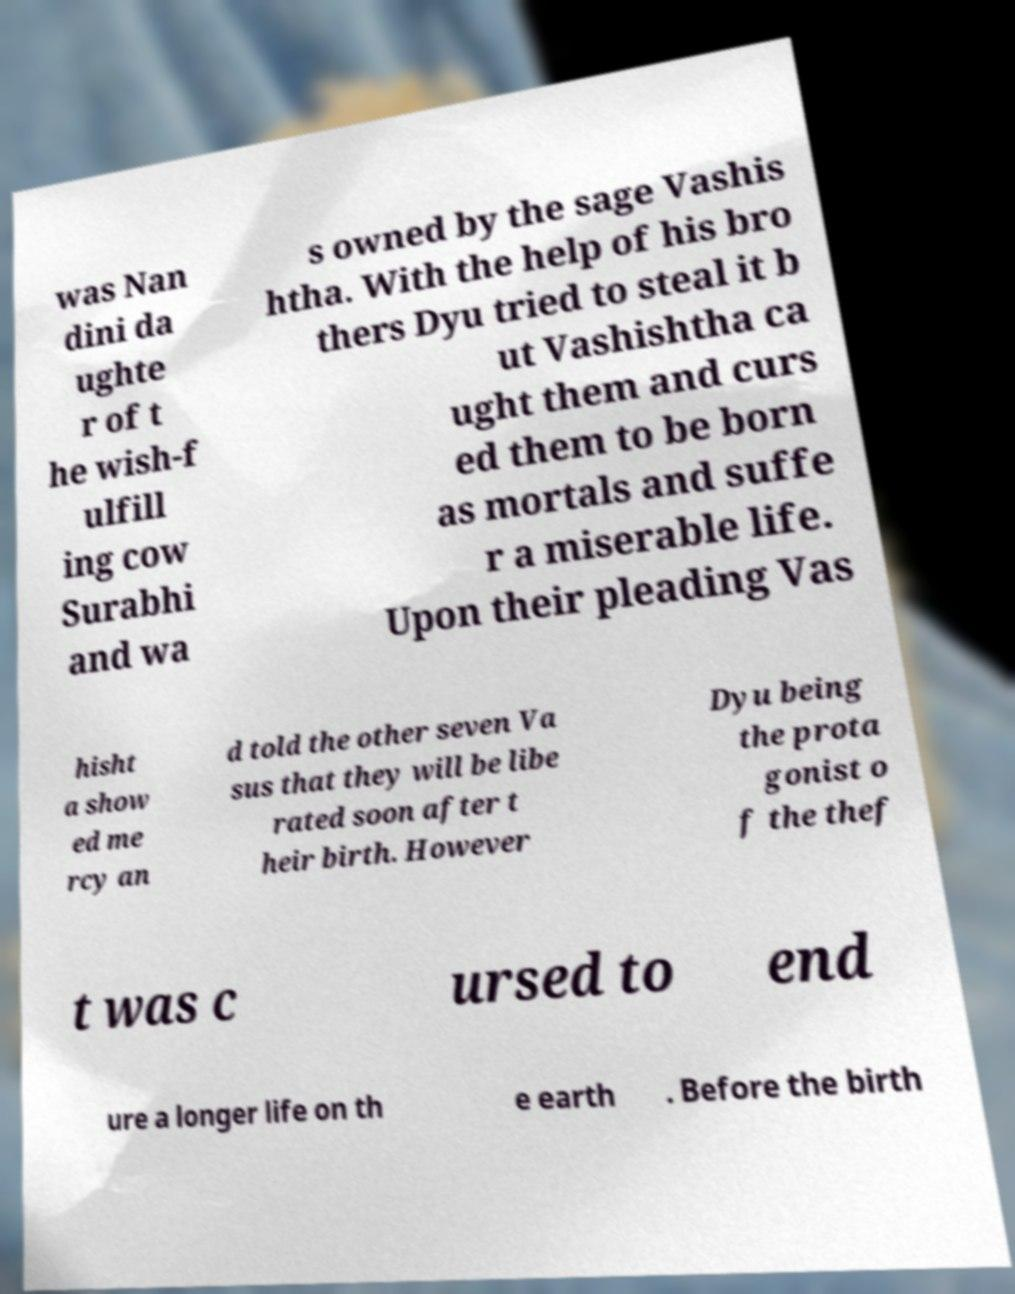For documentation purposes, I need the text within this image transcribed. Could you provide that? was Nan dini da ughte r of t he wish-f ulfill ing cow Surabhi and wa s owned by the sage Vashis htha. With the help of his bro thers Dyu tried to steal it b ut Vashishtha ca ught them and curs ed them to be born as mortals and suffe r a miserable life. Upon their pleading Vas hisht a show ed me rcy an d told the other seven Va sus that they will be libe rated soon after t heir birth. However Dyu being the prota gonist o f the thef t was c ursed to end ure a longer life on th e earth . Before the birth 